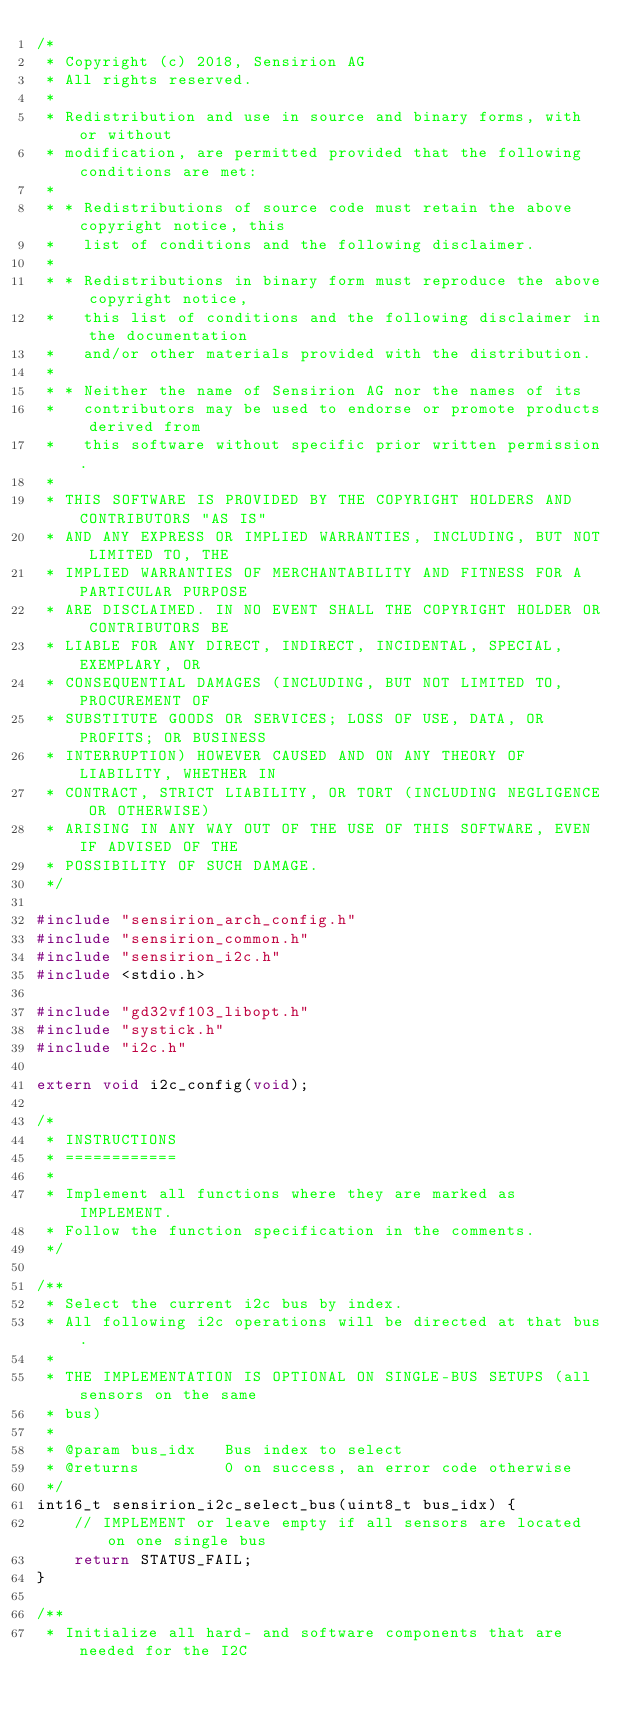<code> <loc_0><loc_0><loc_500><loc_500><_C_>/*
 * Copyright (c) 2018, Sensirion AG
 * All rights reserved.
 *
 * Redistribution and use in source and binary forms, with or without
 * modification, are permitted provided that the following conditions are met:
 *
 * * Redistributions of source code must retain the above copyright notice, this
 *   list of conditions and the following disclaimer.
 *
 * * Redistributions in binary form must reproduce the above copyright notice,
 *   this list of conditions and the following disclaimer in the documentation
 *   and/or other materials provided with the distribution.
 *
 * * Neither the name of Sensirion AG nor the names of its
 *   contributors may be used to endorse or promote products derived from
 *   this software without specific prior written permission.
 *
 * THIS SOFTWARE IS PROVIDED BY THE COPYRIGHT HOLDERS AND CONTRIBUTORS "AS IS"
 * AND ANY EXPRESS OR IMPLIED WARRANTIES, INCLUDING, BUT NOT LIMITED TO, THE
 * IMPLIED WARRANTIES OF MERCHANTABILITY AND FITNESS FOR A PARTICULAR PURPOSE
 * ARE DISCLAIMED. IN NO EVENT SHALL THE COPYRIGHT HOLDER OR CONTRIBUTORS BE
 * LIABLE FOR ANY DIRECT, INDIRECT, INCIDENTAL, SPECIAL, EXEMPLARY, OR
 * CONSEQUENTIAL DAMAGES (INCLUDING, BUT NOT LIMITED TO, PROCUREMENT OF
 * SUBSTITUTE GOODS OR SERVICES; LOSS OF USE, DATA, OR PROFITS; OR BUSINESS
 * INTERRUPTION) HOWEVER CAUSED AND ON ANY THEORY OF LIABILITY, WHETHER IN
 * CONTRACT, STRICT LIABILITY, OR TORT (INCLUDING NEGLIGENCE OR OTHERWISE)
 * ARISING IN ANY WAY OUT OF THE USE OF THIS SOFTWARE, EVEN IF ADVISED OF THE
 * POSSIBILITY OF SUCH DAMAGE.
 */

#include "sensirion_arch_config.h"
#include "sensirion_common.h"
#include "sensirion_i2c.h"
#include <stdio.h>

#include "gd32vf103_libopt.h"
#include "systick.h"
#include "i2c.h"

extern void i2c_config(void);

/*
 * INSTRUCTIONS
 * ============
 *
 * Implement all functions where they are marked as IMPLEMENT.
 * Follow the function specification in the comments.
 */

/**
 * Select the current i2c bus by index.
 * All following i2c operations will be directed at that bus.
 *
 * THE IMPLEMENTATION IS OPTIONAL ON SINGLE-BUS SETUPS (all sensors on the same
 * bus)
 *
 * @param bus_idx   Bus index to select
 * @returns         0 on success, an error code otherwise
 */
int16_t sensirion_i2c_select_bus(uint8_t bus_idx) {
    // IMPLEMENT or leave empty if all sensors are located on one single bus
    return STATUS_FAIL;
}

/**
 * Initialize all hard- and software components that are needed for the I2C</code> 